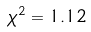Convert formula to latex. <formula><loc_0><loc_0><loc_500><loc_500>\chi ^ { 2 } = 1 . 1 2</formula> 